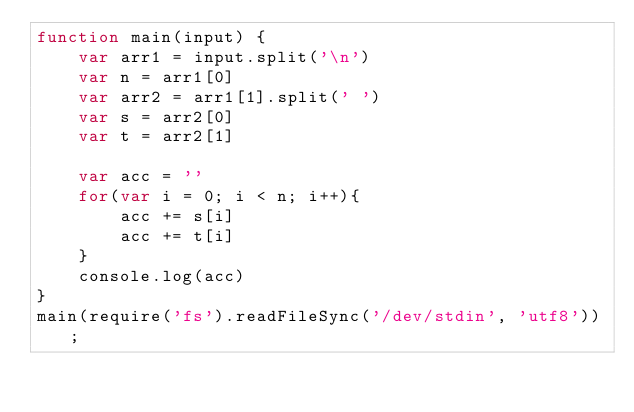<code> <loc_0><loc_0><loc_500><loc_500><_JavaScript_>function main(input) {
    var arr1 = input.split('\n')
    var n = arr1[0]
    var arr2 = arr1[1].split(' ')
    var s = arr2[0]
    var t = arr2[1]
    
    var acc = ''
    for(var i = 0; i < n; i++){
        acc += s[i]
        acc += t[i]
    }
    console.log(acc)
}
main(require('fs').readFileSync('/dev/stdin', 'utf8'));</code> 